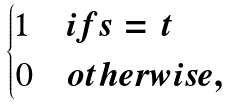<formula> <loc_0><loc_0><loc_500><loc_500>\begin{cases} 1 & i f s = t \\ 0 & o t h e r w i s e , \end{cases}</formula> 